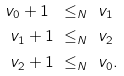<formula> <loc_0><loc_0><loc_500><loc_500>v _ { 0 } + 1 \ & \leq _ { N } \ v _ { 1 } \\ v _ { 1 } + 1 \ & \leq _ { N } \ v _ { 2 } \\ v _ { 2 } + 1 \ & \leq _ { N } \ v _ { 0 } .</formula> 